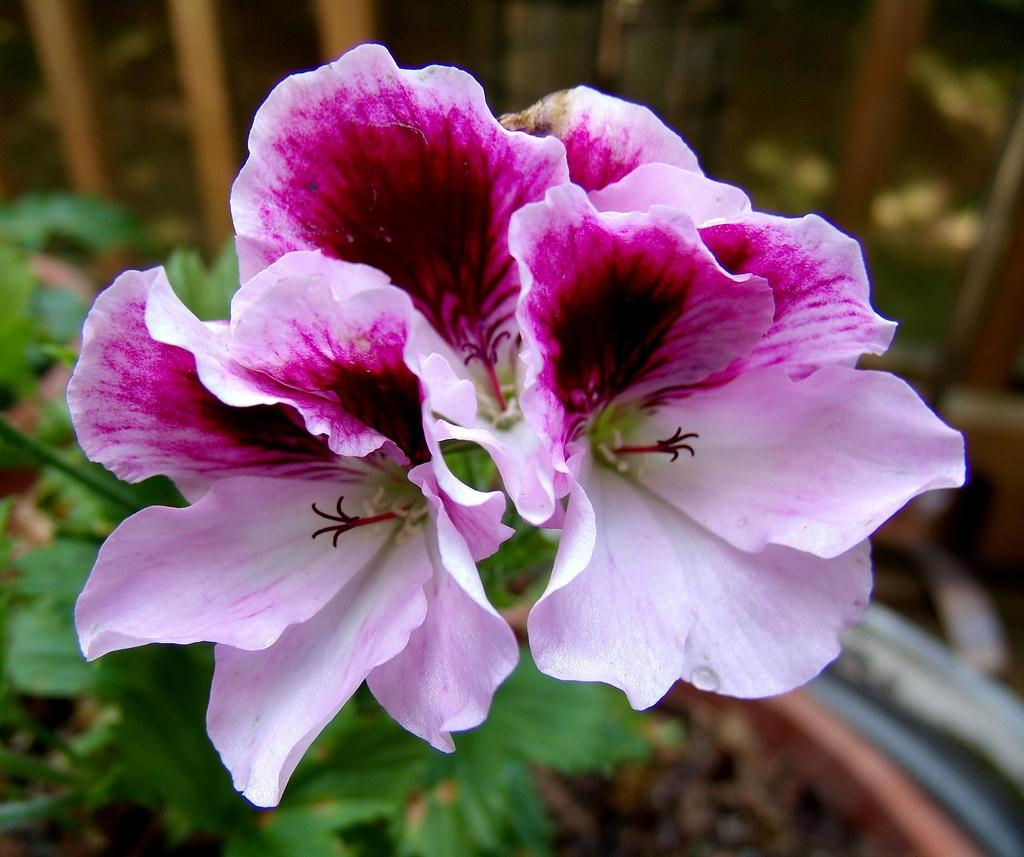What is the main subject in the middle of the image? There is a flower in the middle of the image. What other plant-related object can be seen at the bottom of the image? There is a plant at the bottom of the image. What type of material can be seen in the background of the image? There are wooden sticks in the background of the image. Can you tell me how many berries are on the flower in the image? There are no berries present on the flower in the image. 